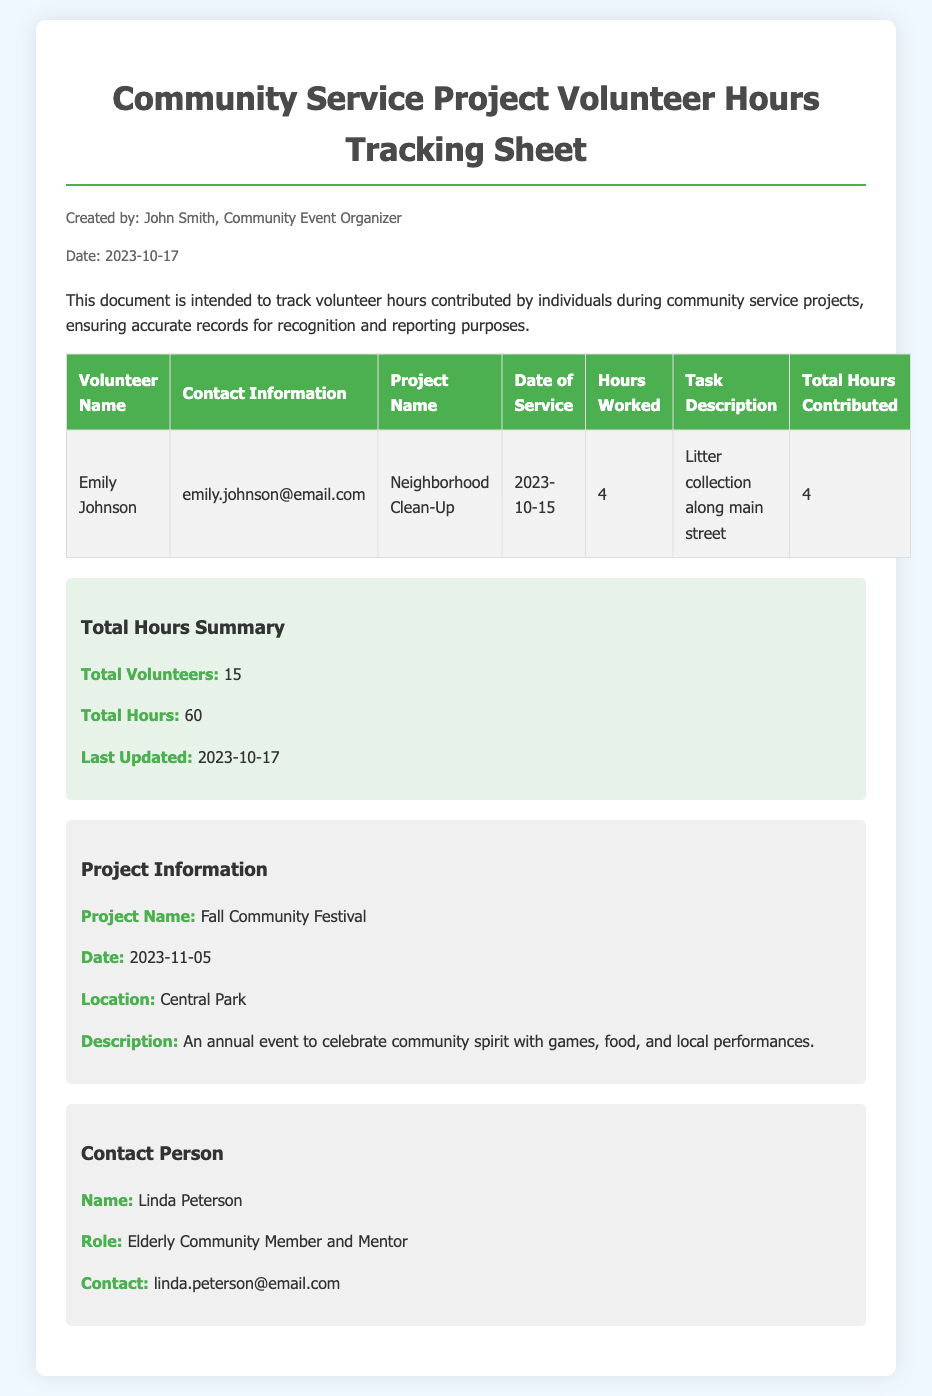What is the name of the organizer? The name of the organizer is provided in the "Created by" section of the document.
Answer: John Smith What is the date of the community service project? The date is mentioned in the "Project Information" section.
Answer: 2023-11-05 Who can be contacted for more information? The "Contact Person" section lists the name and details of the person to contact.
Answer: Linda Peterson How many total hours were contributed by volunteers? The total hours are summarized in the "Total Hours Summary" section.
Answer: 60 What is the task description for Emily Johnson's service? The task description is listed in the row corresponding to Emily Johnson in the table.
Answer: Litter collection along main street How many total volunteers are listed? The total number of volunteers is found in the "Total Hours Summary" section of the document.
Answer: 15 What project was Emily Johnson involved in? Emily Johnson's project is mentioned in the table under "Project Name."
Answer: Neighborhood Clean-Up What is the contact email for Linda Peterson? The contact email is provided in the "Contact Person" section.
Answer: linda.peterson@email.com 